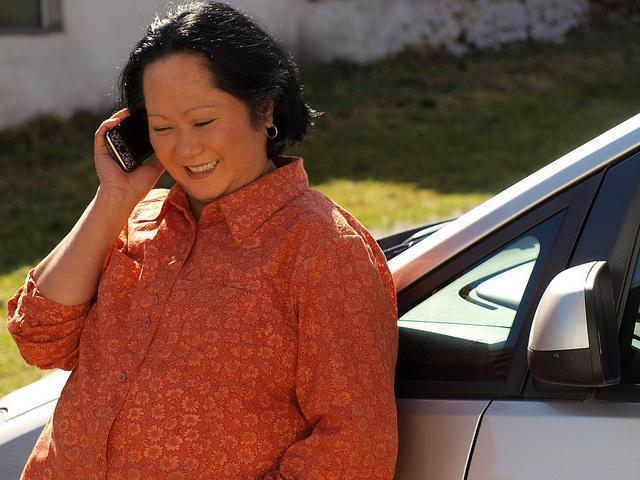How many people in this image are dragging a suitcase behind them?
Give a very brief answer. 0. 